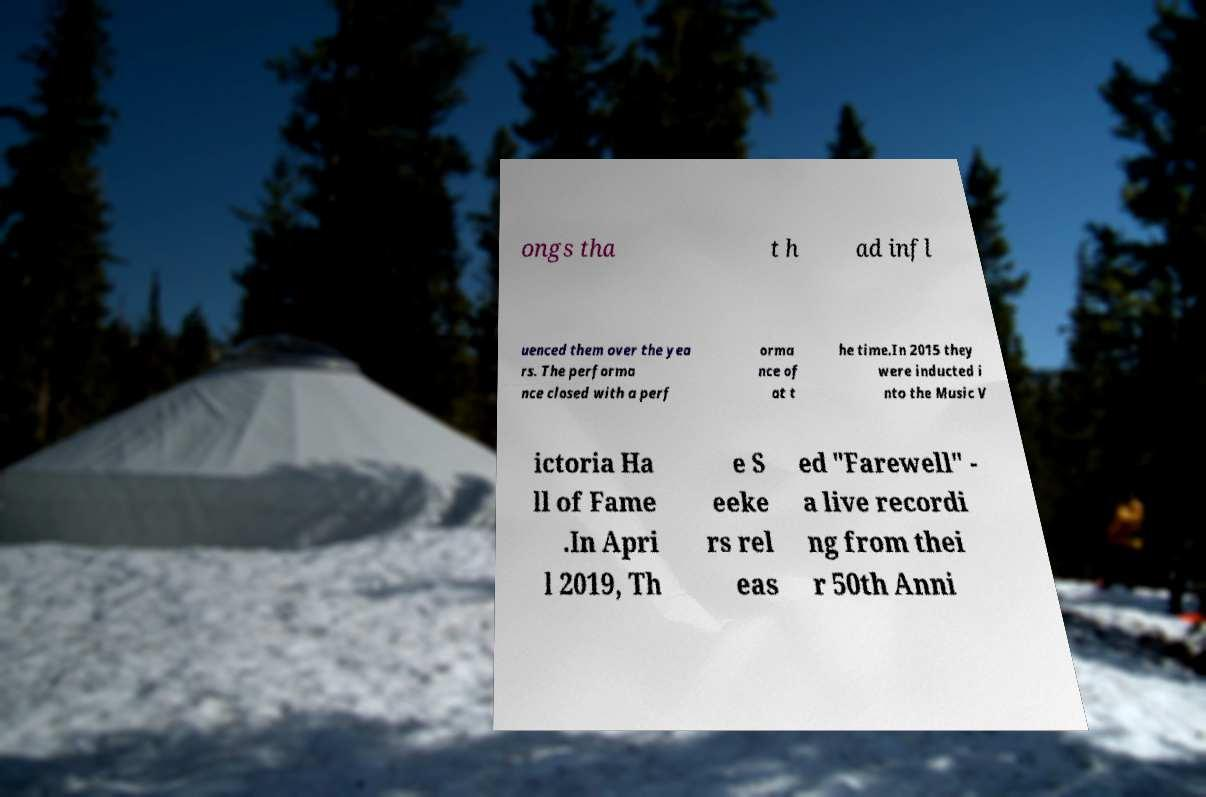Please identify and transcribe the text found in this image. ongs tha t h ad infl uenced them over the yea rs. The performa nce closed with a perf orma nce of at t he time.In 2015 they were inducted i nto the Music V ictoria Ha ll of Fame .In Apri l 2019, Th e S eeke rs rel eas ed "Farewell" - a live recordi ng from thei r 50th Anni 